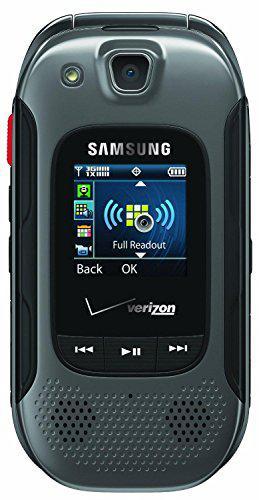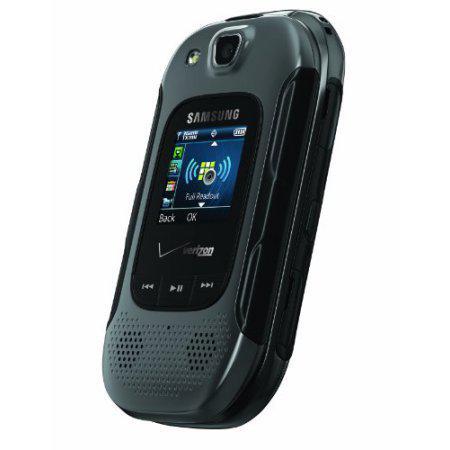The first image is the image on the left, the second image is the image on the right. Examine the images to the left and right. Is the description "The left and right image contains the same number of flip phones." accurate? Answer yes or no. Yes. The first image is the image on the left, the second image is the image on the right. Examine the images to the left and right. Is the description "Each image contains a single phone, and the phone in the right image has its top at least partially flipped open." accurate? Answer yes or no. No. 